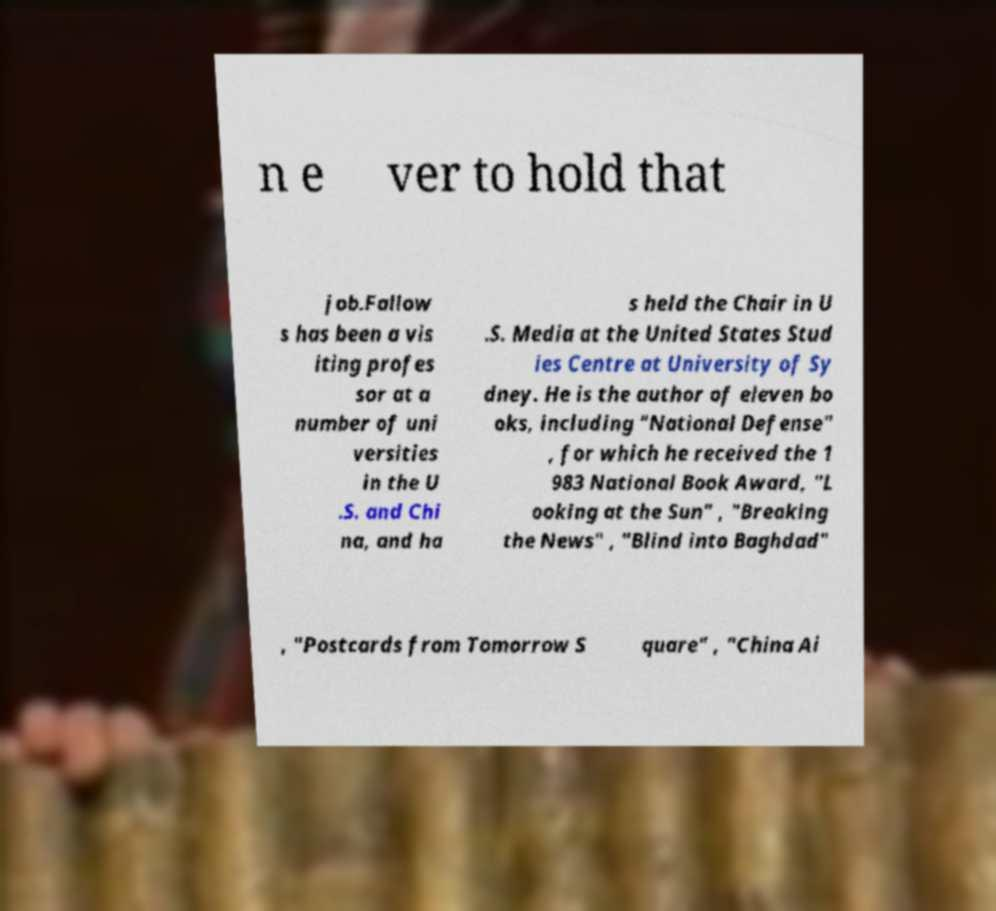Please read and relay the text visible in this image. What does it say? n e ver to hold that job.Fallow s has been a vis iting profes sor at a number of uni versities in the U .S. and Chi na, and ha s held the Chair in U .S. Media at the United States Stud ies Centre at University of Sy dney. He is the author of eleven bo oks, including "National Defense" , for which he received the 1 983 National Book Award, "L ooking at the Sun" , "Breaking the News" , "Blind into Baghdad" , "Postcards from Tomorrow S quare" , "China Ai 